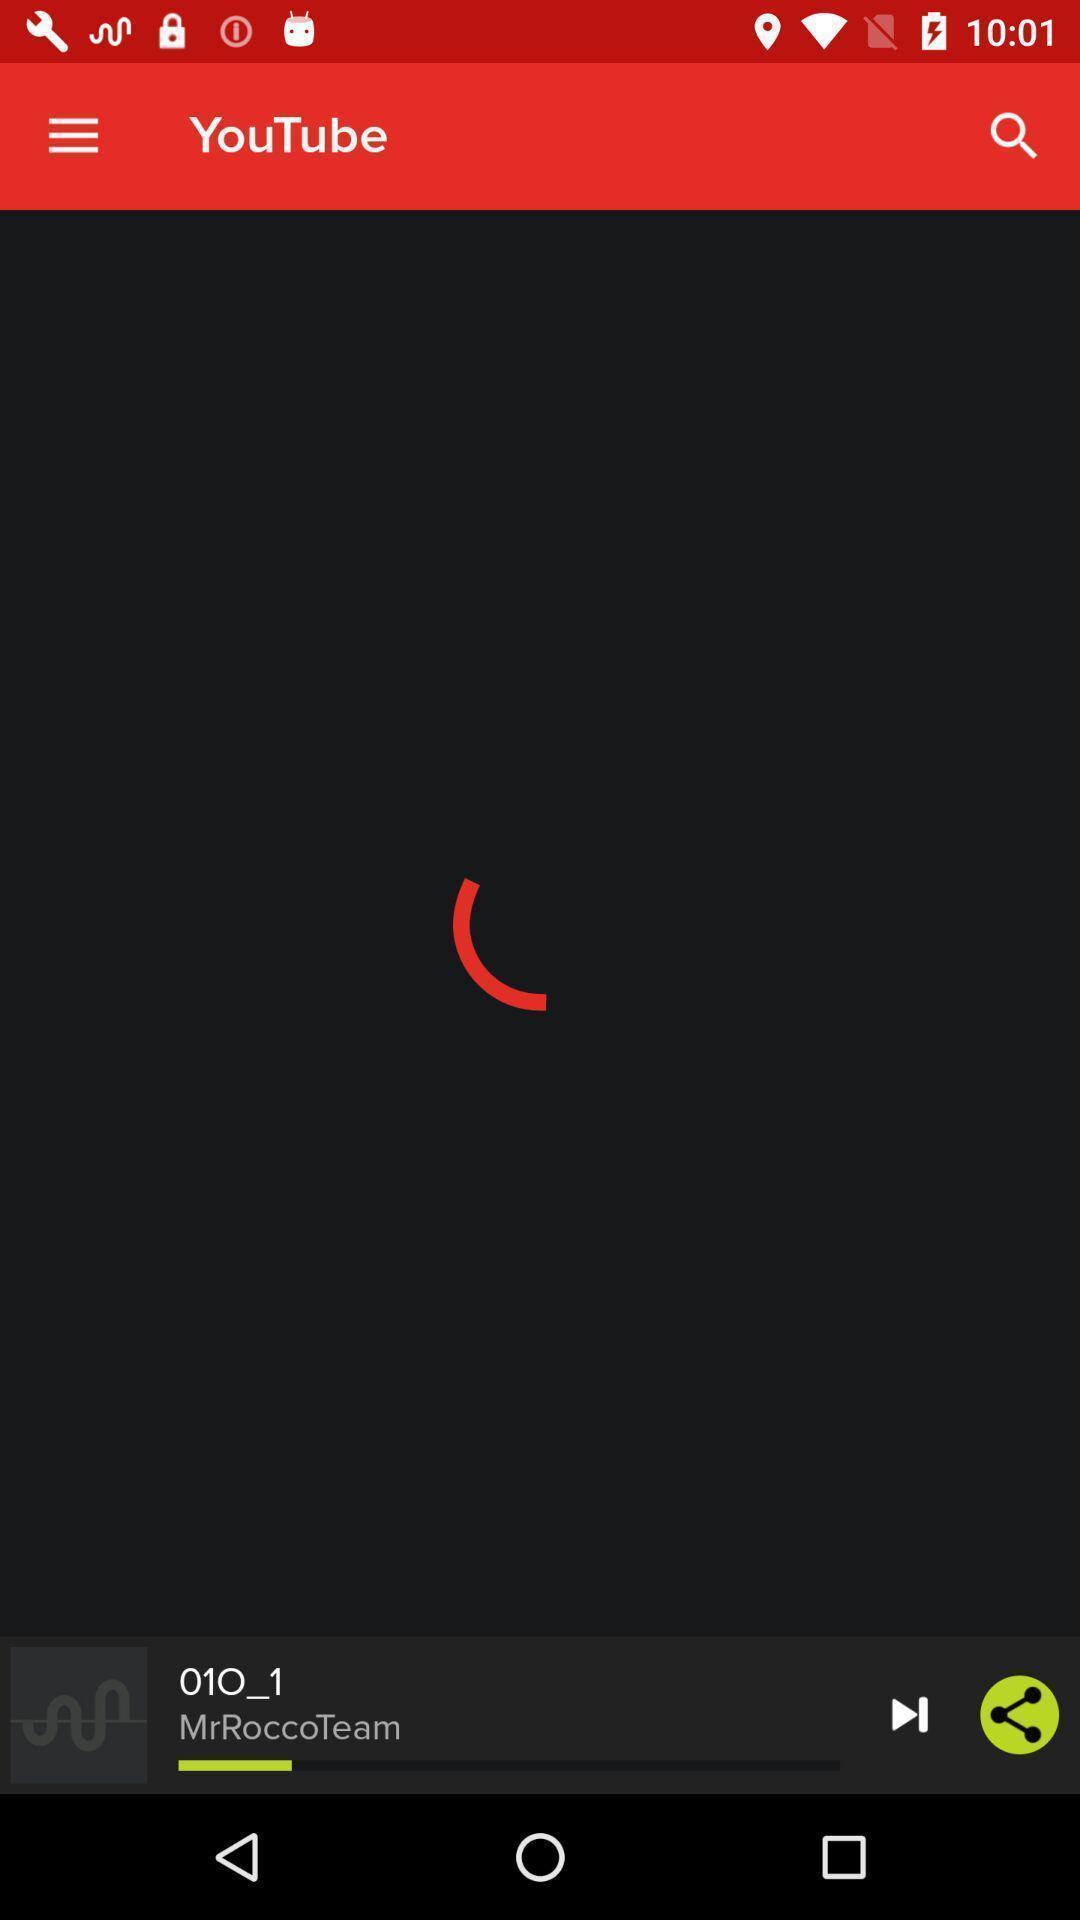Explain the elements present in this screenshot. Page displaying a loading symbol. 